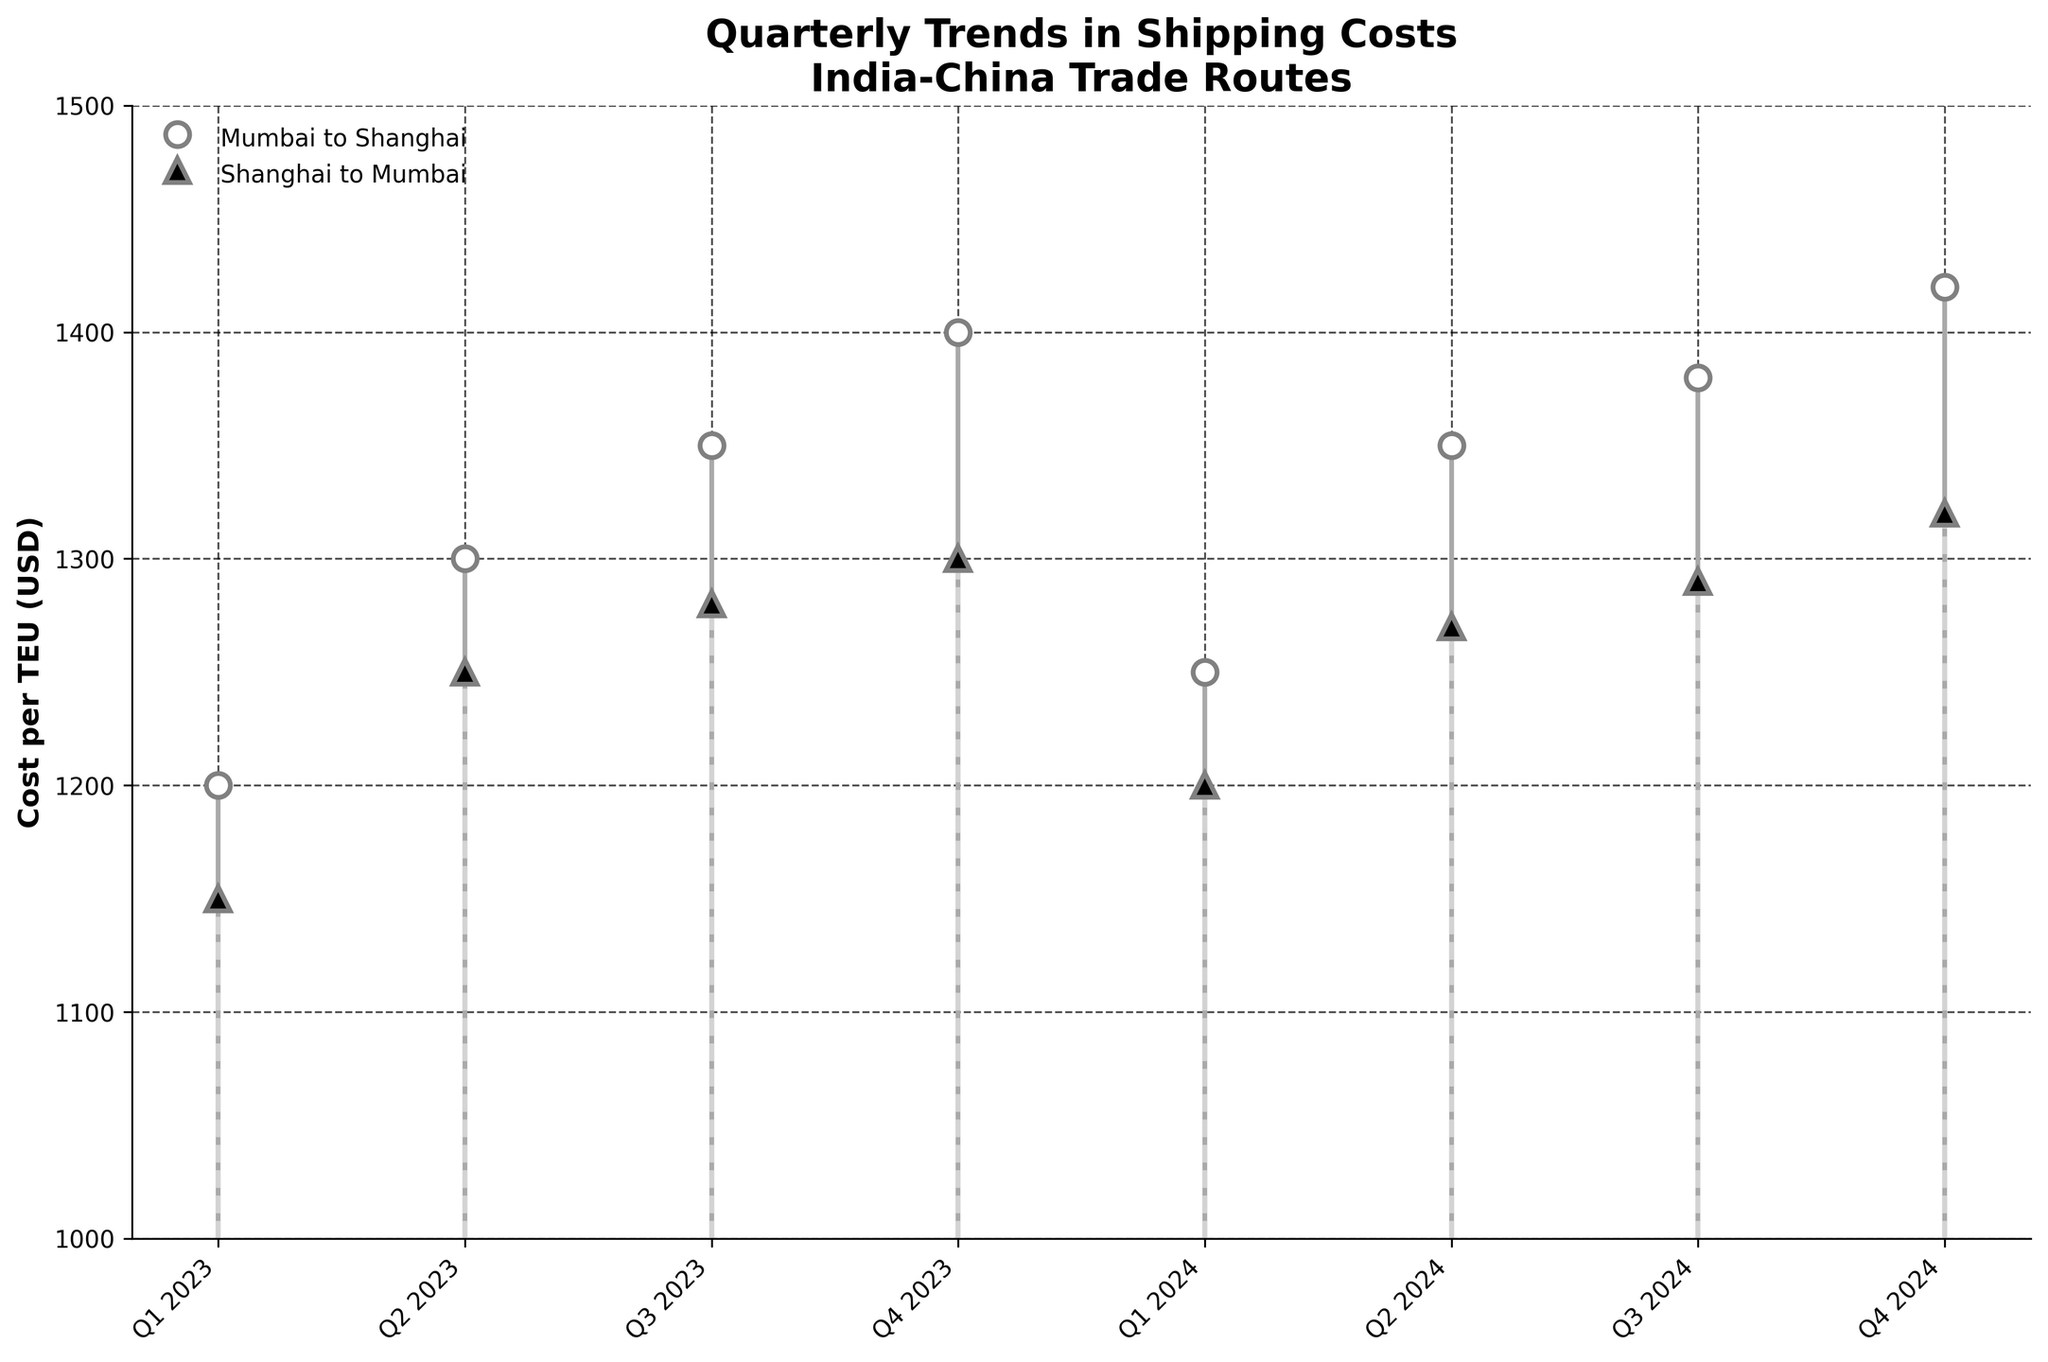What is the title of the figure? The title of the figure is always located at the top and summarizes the visualized data. Here, the title is provided in bold text.
Answer: Quarterly Trends in Shipping Costs for India-China Trade Routes What is represented on the y-axis? The y-axis label is typically located next to the y-axis, providing information on what the values represent.
Answer: Cost per TEU (USD) What are the different shipping routes shown on the stem plot? The legend indicates the different shipping routes visualized by using different markers and colors. By examining the legend, we can see the distinct routes.
Answer: Mumbai to Shanghai and Shanghai to Mumbai Which quarter has the highest shipping cost from Mumbai to Shanghai? By inspecting the stem plot, we identify the highest point for the Mumbai to Shanghai route.
Answer: Q4 2024 What is the difference in shipping costs between Mumbai to Shanghai and Shanghai to Mumbai in Q4 2023? We need to identify the respective costs for both routes in Q4 2023 and then find the difference. From the plot, Mumbai to Shanghai is at 1400 USD and Shanghai to Mumbai is at 1300 USD. The difference is 1400 - 1300.
Answer: 100 USD In which quarter of 2023 was the shipping cost for the Shanghai to Mumbai route the lowest? To find the lowest cost, we need to examine all the quarters in 2023 for the Shanghai to Mumbai route and identify the quarter with the lowest value.
Answer: Q1 2023 How did the shipping cost trend for Mumbai to Shanghai from Q1 2023 to Q4 2023? To determine the trend, observe the stem points for Mumbai to Shanghai from Q1 to Q4 2023 and describe the pattern either increasing, decreasing, or stable.
Answer: Increasing What is the average shipping cost for the Shanghai to Mumbai route over the entire period? Calculate the average by summing all the costs for the Shanghai to Mumbai route and dividing by the number of quarters. (1150 + 1250 + 1280 + 1300 + 1200 + 1270 + 1290 + 1320) / 8
Answer: 1257.5 USD Which quarter has the smallest difference between the shipping costs of the two routes? For each quarter, compute the difference between the costs of the two routes and identify which quarter has the smallest absolute difference.
Answer: Q1 2024 